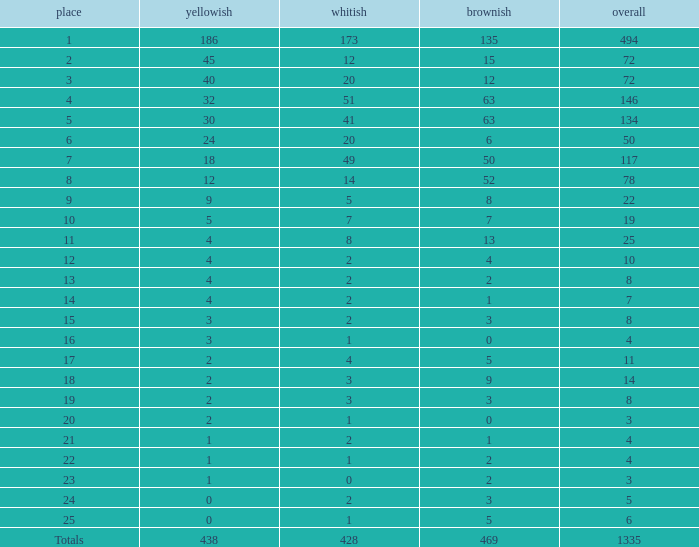What is the average number of gold medals when the total was 1335 medals, with more than 469 bronzes and more than 14 silvers? None. 